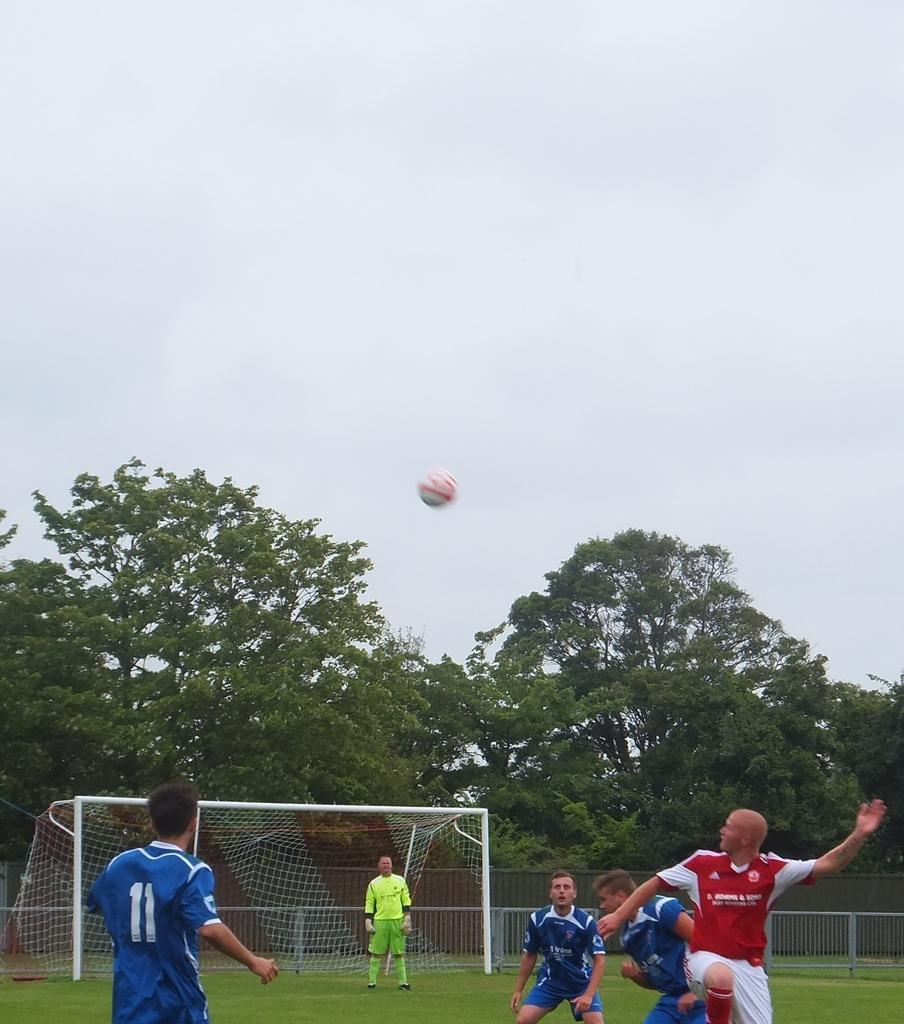What activity are the people in the image engaged in? The people in the image are playing football. Where is the football game taking place? The football game is taking place on a ground. What can be seen in the background of the image? There are many trees visible behind the ground. What type of organization is responsible for the corn growing in the image? There is no corn present in the image, so it is not possible to determine which organization might be responsible for its growth. 